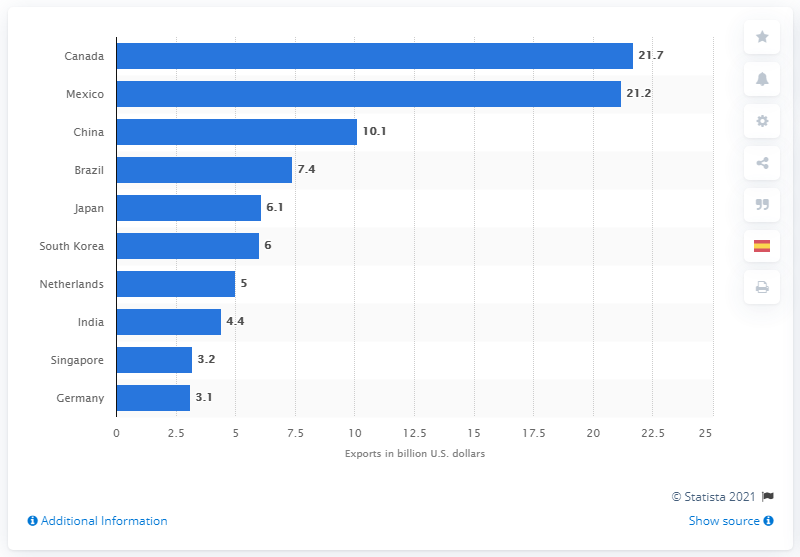Point out several critical features in this image. In 2019, Canada was the leading destination country for U.S. chemical exports, accounting for the majority of these exports. 